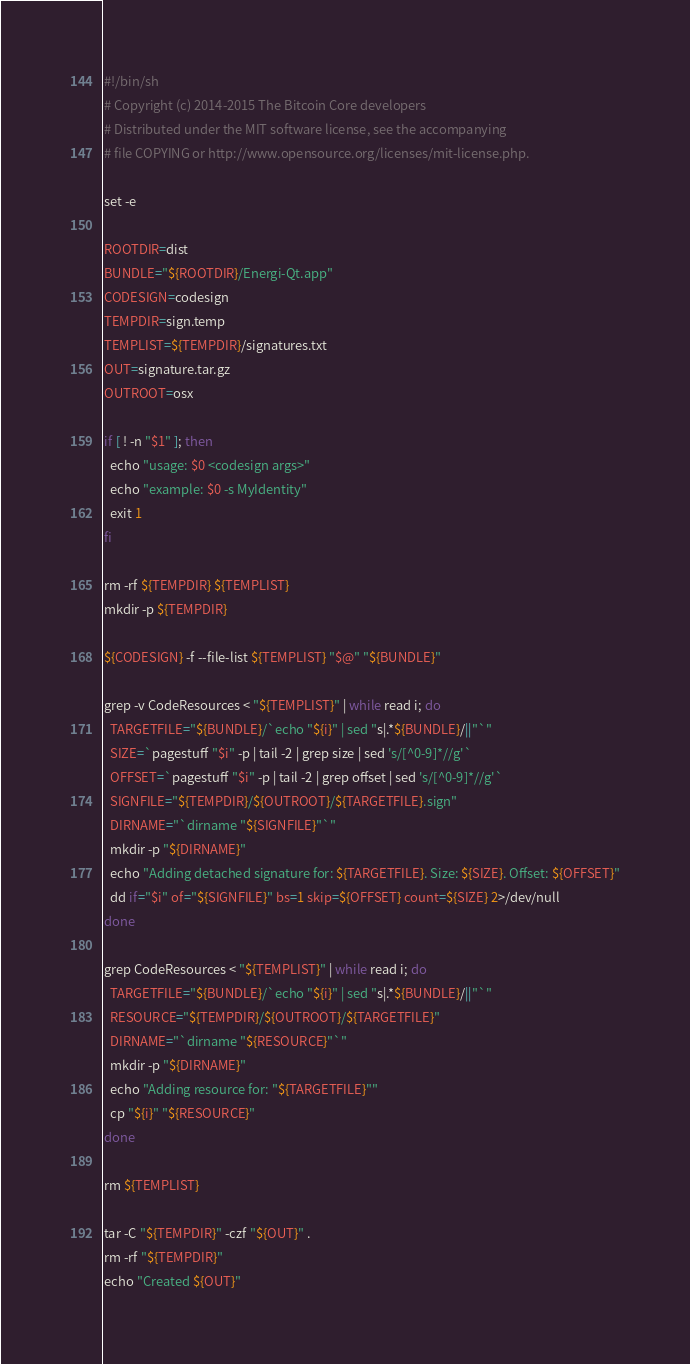<code> <loc_0><loc_0><loc_500><loc_500><_Bash_>#!/bin/sh
# Copyright (c) 2014-2015 The Bitcoin Core developers
# Distributed under the MIT software license, see the accompanying
# file COPYING or http://www.opensource.org/licenses/mit-license.php.

set -e

ROOTDIR=dist
BUNDLE="${ROOTDIR}/Energi-Qt.app"
CODESIGN=codesign
TEMPDIR=sign.temp
TEMPLIST=${TEMPDIR}/signatures.txt
OUT=signature.tar.gz
OUTROOT=osx

if [ ! -n "$1" ]; then
  echo "usage: $0 <codesign args>"
  echo "example: $0 -s MyIdentity"
  exit 1
fi

rm -rf ${TEMPDIR} ${TEMPLIST}
mkdir -p ${TEMPDIR}

${CODESIGN} -f --file-list ${TEMPLIST} "$@" "${BUNDLE}"

grep -v CodeResources < "${TEMPLIST}" | while read i; do
  TARGETFILE="${BUNDLE}/`echo "${i}" | sed "s|.*${BUNDLE}/||"`"
  SIZE=`pagestuff "$i" -p | tail -2 | grep size | sed 's/[^0-9]*//g'`
  OFFSET=`pagestuff "$i" -p | tail -2 | grep offset | sed 's/[^0-9]*//g'`
  SIGNFILE="${TEMPDIR}/${OUTROOT}/${TARGETFILE}.sign"
  DIRNAME="`dirname "${SIGNFILE}"`"
  mkdir -p "${DIRNAME}"
  echo "Adding detached signature for: ${TARGETFILE}. Size: ${SIZE}. Offset: ${OFFSET}"
  dd if="$i" of="${SIGNFILE}" bs=1 skip=${OFFSET} count=${SIZE} 2>/dev/null
done

grep CodeResources < "${TEMPLIST}" | while read i; do
  TARGETFILE="${BUNDLE}/`echo "${i}" | sed "s|.*${BUNDLE}/||"`"
  RESOURCE="${TEMPDIR}/${OUTROOT}/${TARGETFILE}"
  DIRNAME="`dirname "${RESOURCE}"`"
  mkdir -p "${DIRNAME}"
  echo "Adding resource for: "${TARGETFILE}""
  cp "${i}" "${RESOURCE}"
done

rm ${TEMPLIST}

tar -C "${TEMPDIR}" -czf "${OUT}" .
rm -rf "${TEMPDIR}"
echo "Created ${OUT}"
</code> 